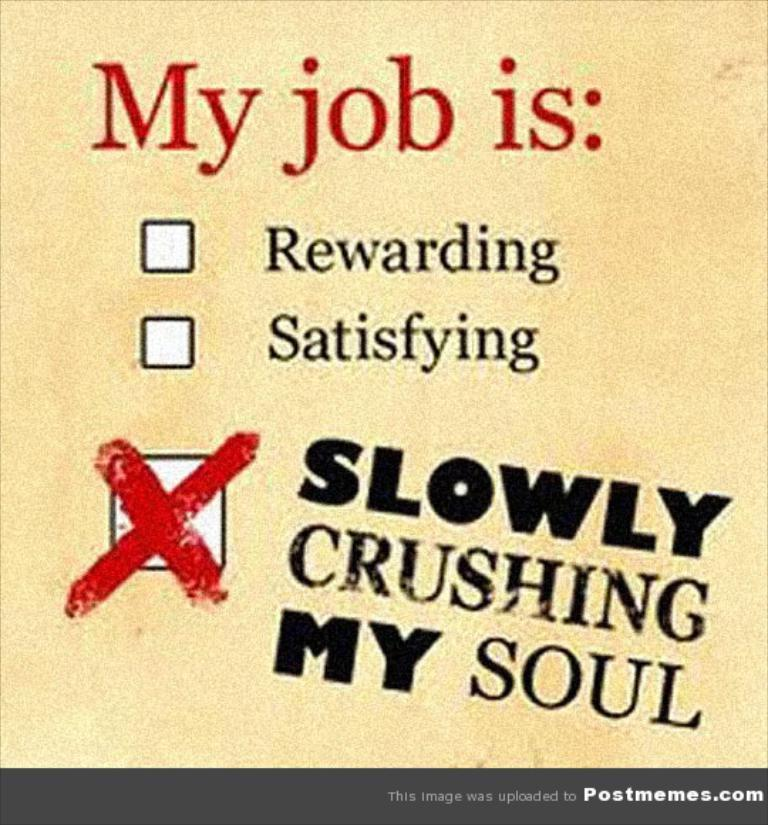<image>
Provide a brief description of the given image. A meme reads that "my job is: slowly crushing my soul." 